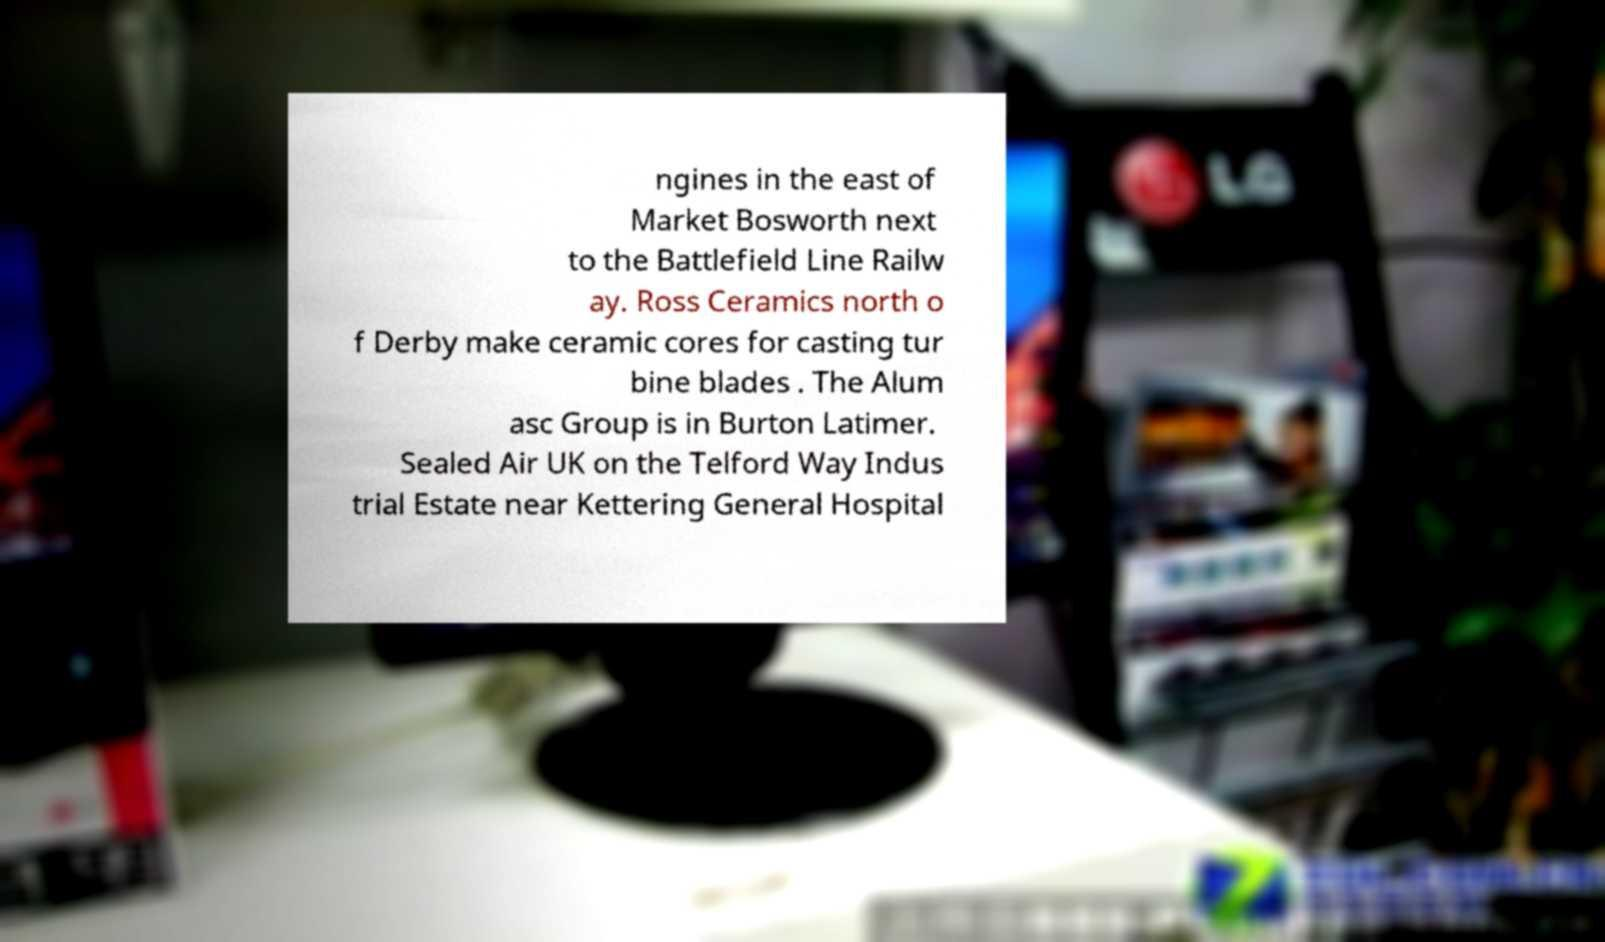There's text embedded in this image that I need extracted. Can you transcribe it verbatim? ngines in the east of Market Bosworth next to the Battlefield Line Railw ay. Ross Ceramics north o f Derby make ceramic cores for casting tur bine blades . The Alum asc Group is in Burton Latimer. Sealed Air UK on the Telford Way Indus trial Estate near Kettering General Hospital 